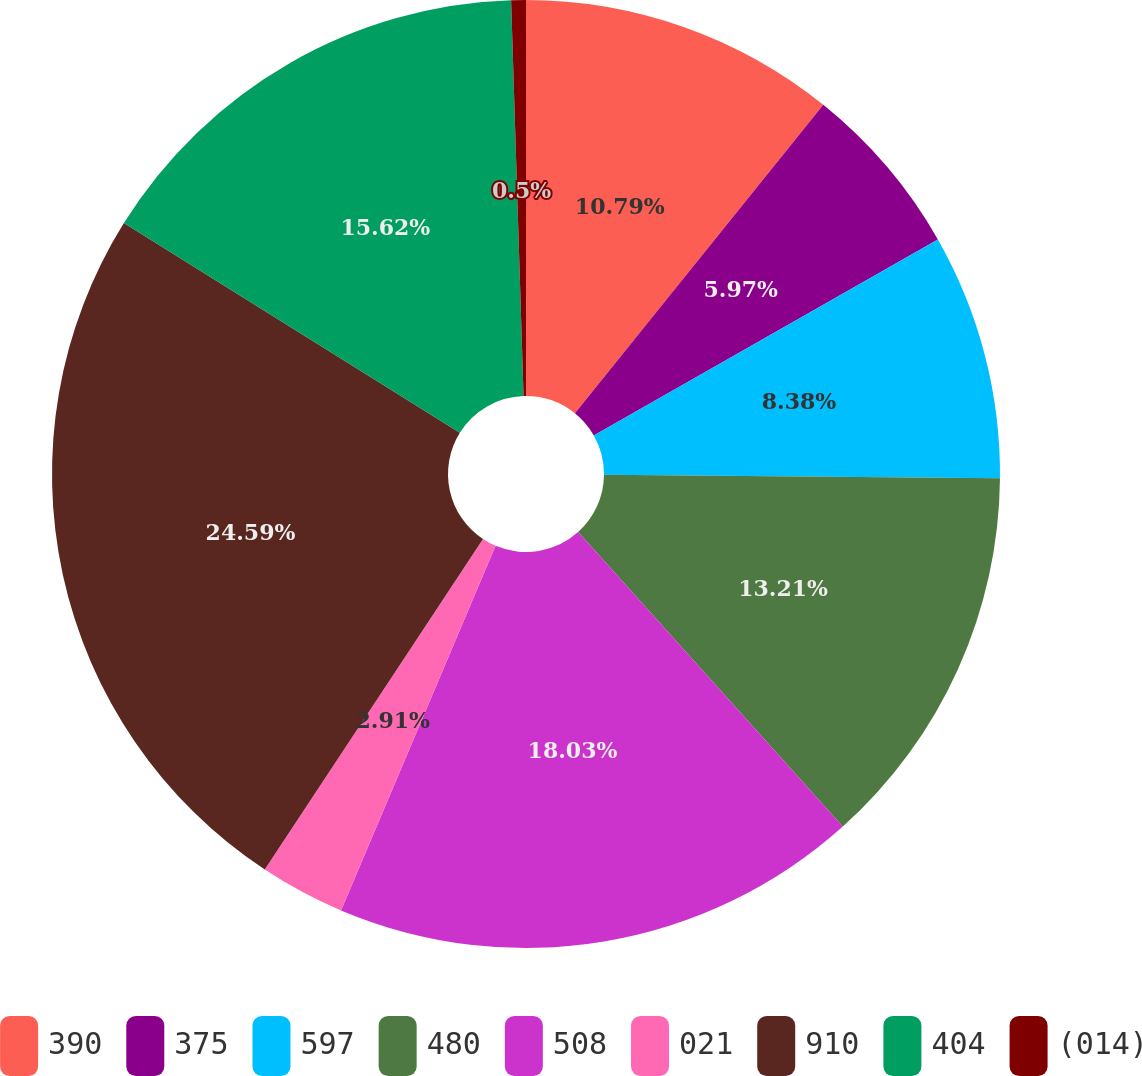Convert chart. <chart><loc_0><loc_0><loc_500><loc_500><pie_chart><fcel>390<fcel>375<fcel>597<fcel>480<fcel>508<fcel>021<fcel>910<fcel>404<fcel>(014)<nl><fcel>10.79%<fcel>5.97%<fcel>8.38%<fcel>13.21%<fcel>18.03%<fcel>2.91%<fcel>24.59%<fcel>15.62%<fcel>0.5%<nl></chart> 